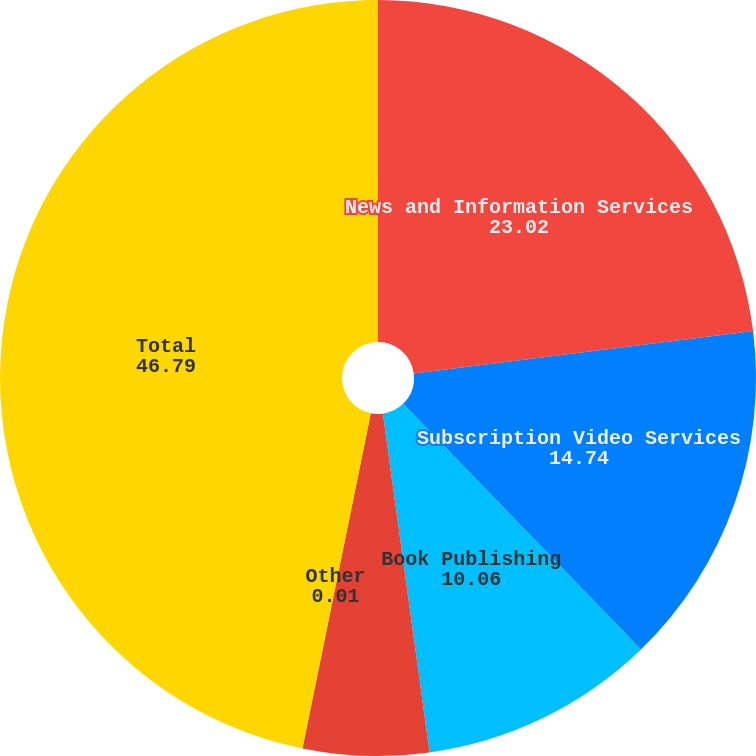Convert chart to OTSL. <chart><loc_0><loc_0><loc_500><loc_500><pie_chart><fcel>News and Information Services<fcel>Subscription Video Services<fcel>Book Publishing<fcel>Digital Real Estate Services<fcel>Other<fcel>Total<nl><fcel>23.02%<fcel>14.74%<fcel>10.06%<fcel>5.38%<fcel>0.01%<fcel>46.79%<nl></chart> 